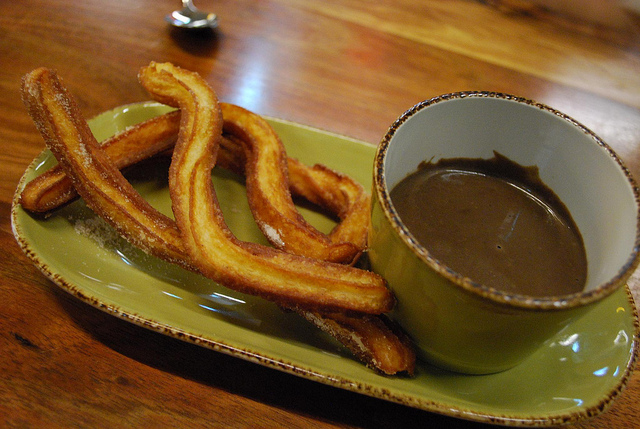What color is the dish? The dish is a vibrant green, which highlights the golden color of the churros. 